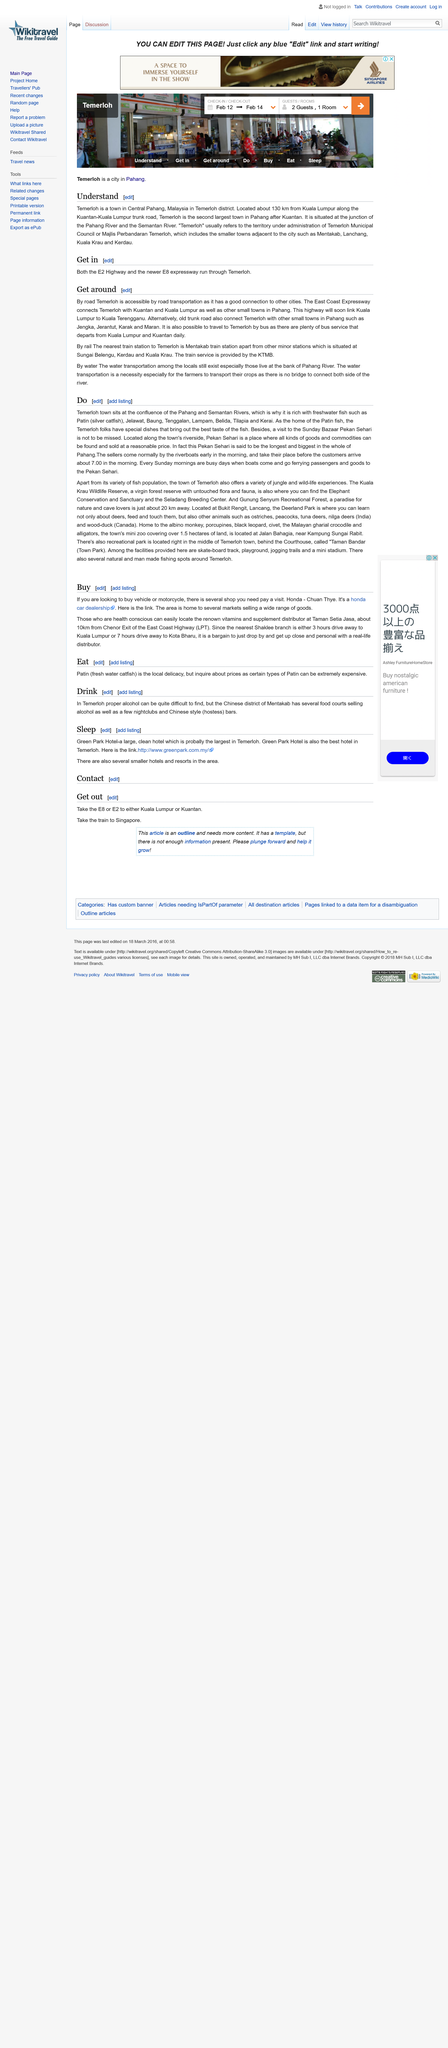List a handful of essential elements in this visual. There is no bridge connecting the banks of the Pahang River. The Mentakab train station is the nearest train station to Temerloh, as stated. When getting around from Temerloh, the East Coast Expressway is commonly used. 